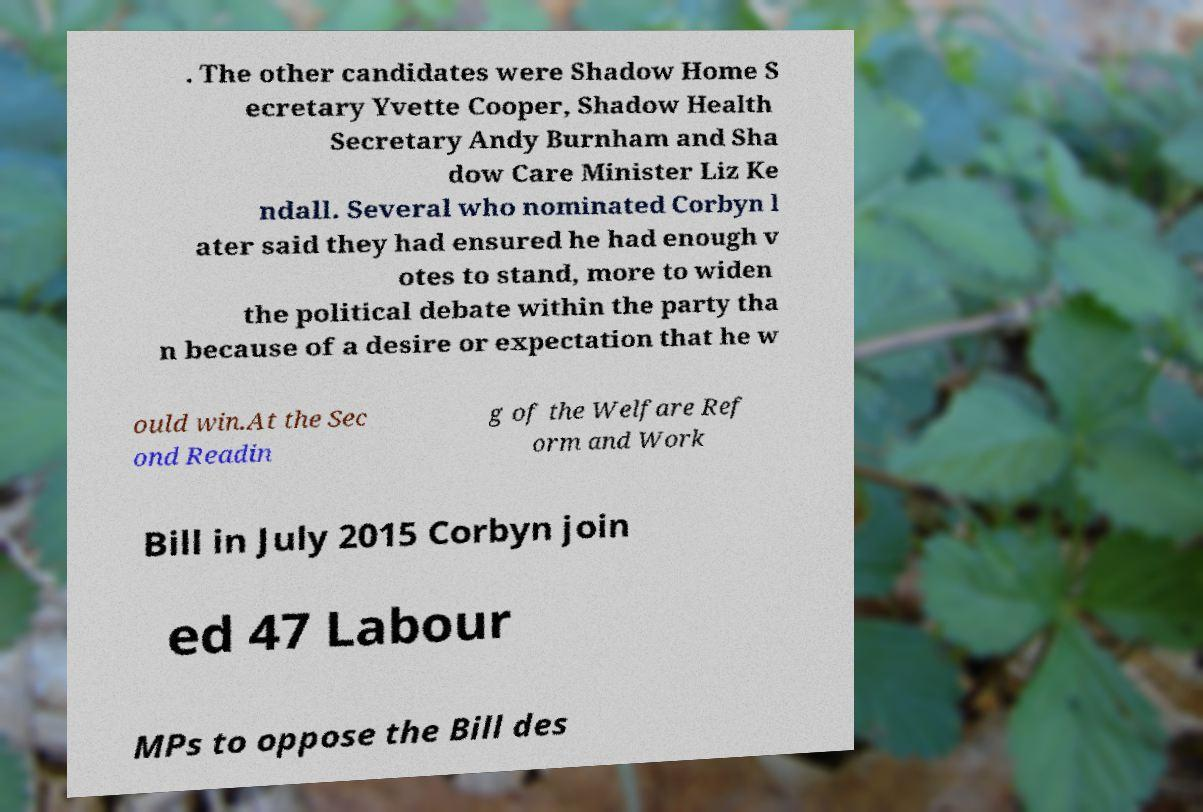There's text embedded in this image that I need extracted. Can you transcribe it verbatim? . The other candidates were Shadow Home S ecretary Yvette Cooper, Shadow Health Secretary Andy Burnham and Sha dow Care Minister Liz Ke ndall. Several who nominated Corbyn l ater said they had ensured he had enough v otes to stand, more to widen the political debate within the party tha n because of a desire or expectation that he w ould win.At the Sec ond Readin g of the Welfare Ref orm and Work Bill in July 2015 Corbyn join ed 47 Labour MPs to oppose the Bill des 